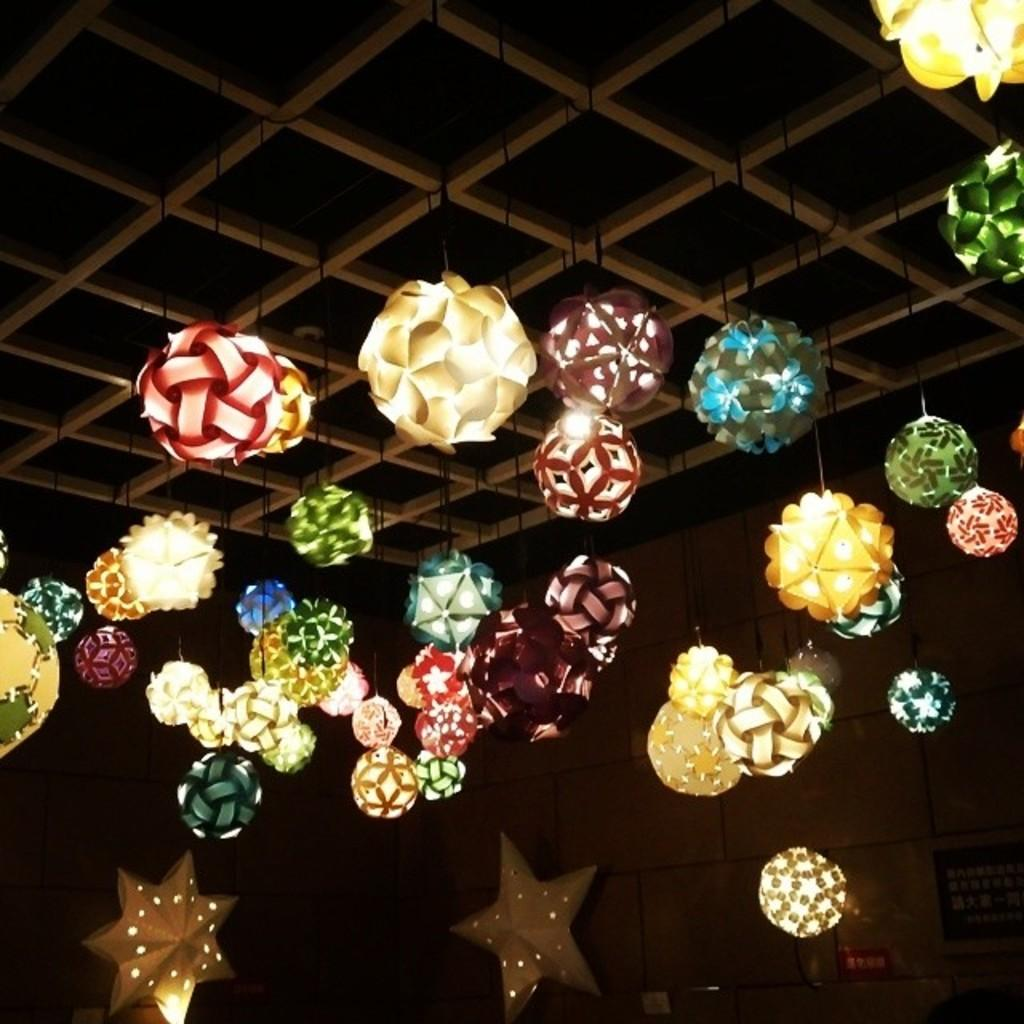What can be seen in the image that provides illumination? There are lights in the image. What type of stew is being cooked on the channel in the image? There is no channel or stew present in the image; it only features lights. 